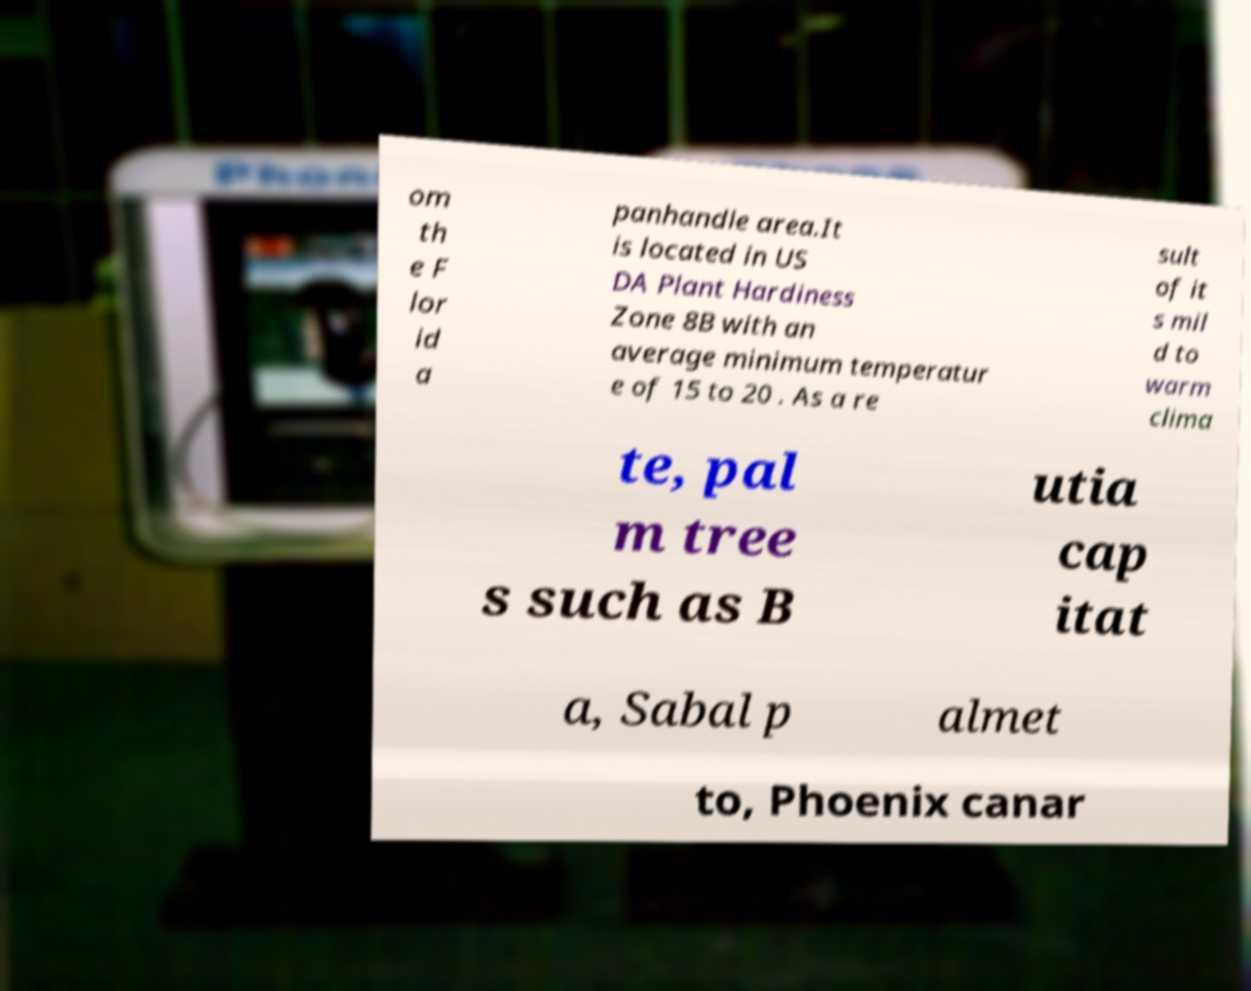Can you accurately transcribe the text from the provided image for me? om th e F lor id a panhandle area.It is located in US DA Plant Hardiness Zone 8B with an average minimum temperatur e of 15 to 20 . As a re sult of it s mil d to warm clima te, pal m tree s such as B utia cap itat a, Sabal p almet to, Phoenix canar 